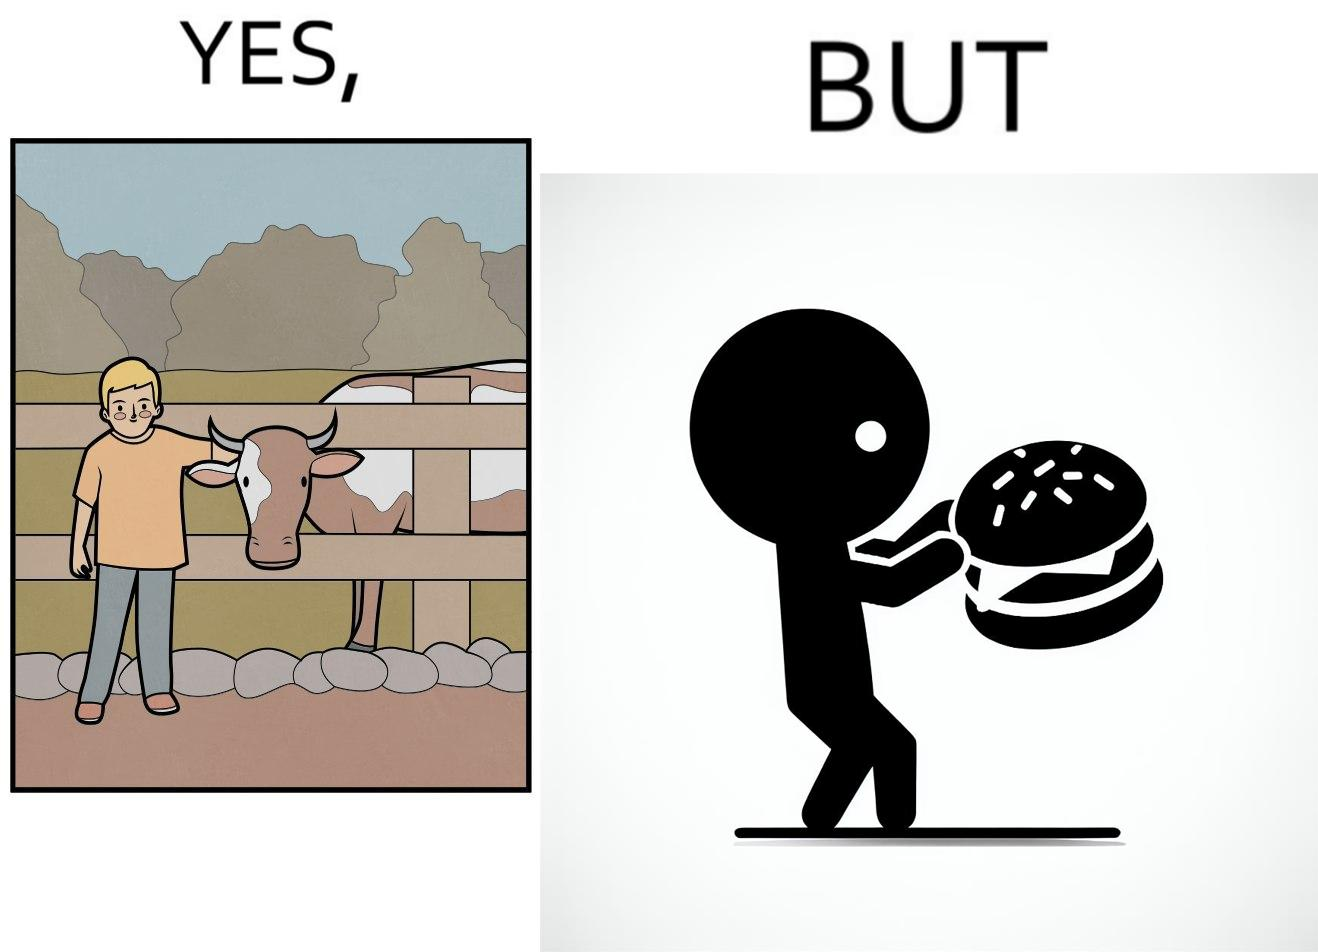Describe the contrast between the left and right parts of this image. In the left part of the image: A boy petting a cow In the right part of the image: A boy eating a hamburger 